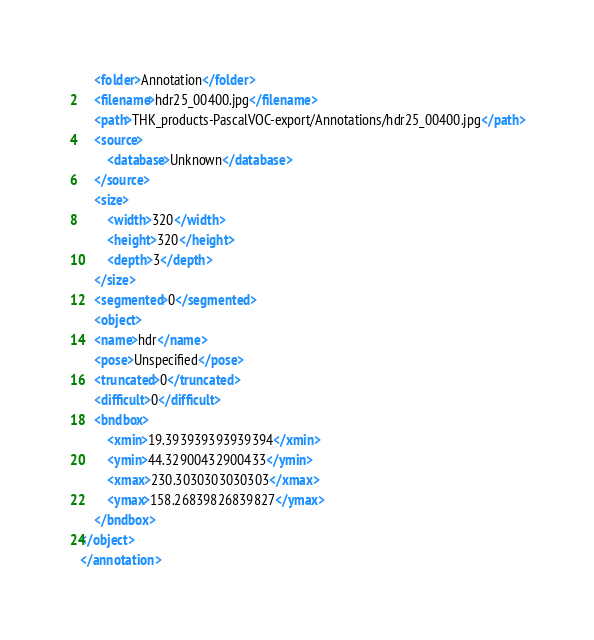<code> <loc_0><loc_0><loc_500><loc_500><_XML_>    <folder>Annotation</folder>
    <filename>hdr25_00400.jpg</filename>
    <path>THK_products-PascalVOC-export/Annotations/hdr25_00400.jpg</path>
    <source>
        <database>Unknown</database>
    </source>
    <size>
        <width>320</width>
        <height>320</height>
        <depth>3</depth>
    </size>
    <segmented>0</segmented>
    <object>
    <name>hdr</name>
    <pose>Unspecified</pose>
    <truncated>0</truncated>
    <difficult>0</difficult>
    <bndbox>
        <xmin>19.393939393939394</xmin>
        <ymin>44.32900432900433</ymin>
        <xmax>230.3030303030303</xmax>
        <ymax>158.26839826839827</ymax>
    </bndbox>
</object>
</annotation>
</code> 